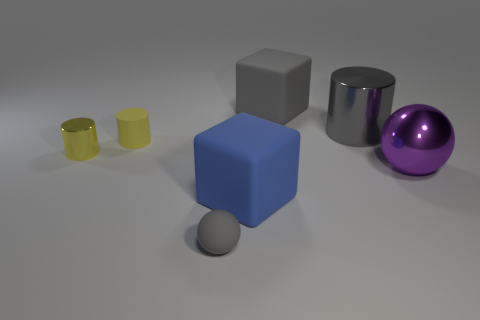Does the gray ball have the same material as the tiny yellow thing that is left of the yellow rubber thing?
Your answer should be compact. No. There is a rubber block behind the matte cylinder; is it the same color as the big metal sphere?
Give a very brief answer. No. What number of objects are both behind the small yellow metallic object and in front of the big gray cylinder?
Offer a terse response. 1. What number of other objects are there of the same material as the purple ball?
Keep it short and to the point. 2. Does the large cube on the right side of the large blue cube have the same material as the purple thing?
Your response must be concise. No. There is a ball that is to the right of the large rubber thing that is left of the gray rubber thing to the right of the small gray rubber sphere; what size is it?
Offer a terse response. Large. What number of other objects are the same color as the large metallic cylinder?
Your answer should be very brief. 2. The other metallic object that is the same size as the purple object is what shape?
Your response must be concise. Cylinder. What is the size of the matte ball in front of the tiny yellow shiny cylinder?
Keep it short and to the point. Small. There is a cube behind the tiny yellow metal object; is it the same color as the sphere on the right side of the small gray thing?
Your answer should be very brief. No. 